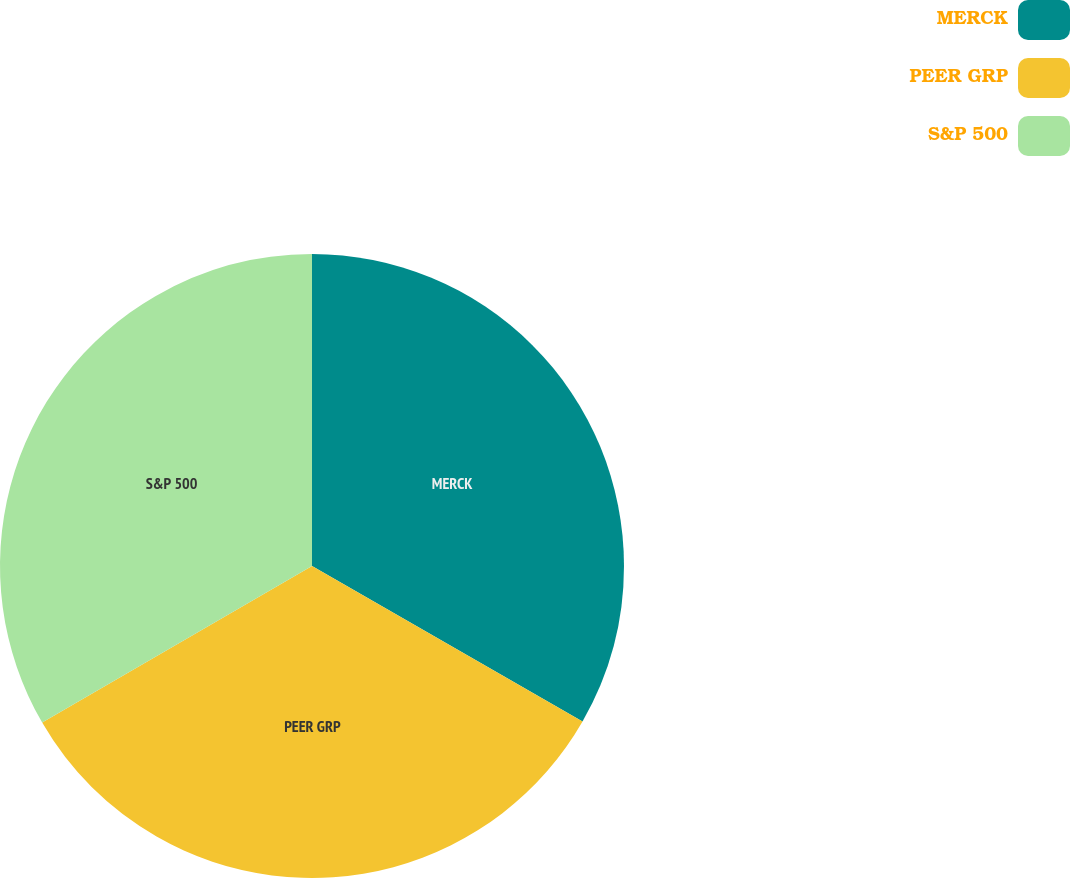Convert chart to OTSL. <chart><loc_0><loc_0><loc_500><loc_500><pie_chart><fcel>MERCK<fcel>PEER GRP<fcel>S&P 500<nl><fcel>33.3%<fcel>33.33%<fcel>33.37%<nl></chart> 